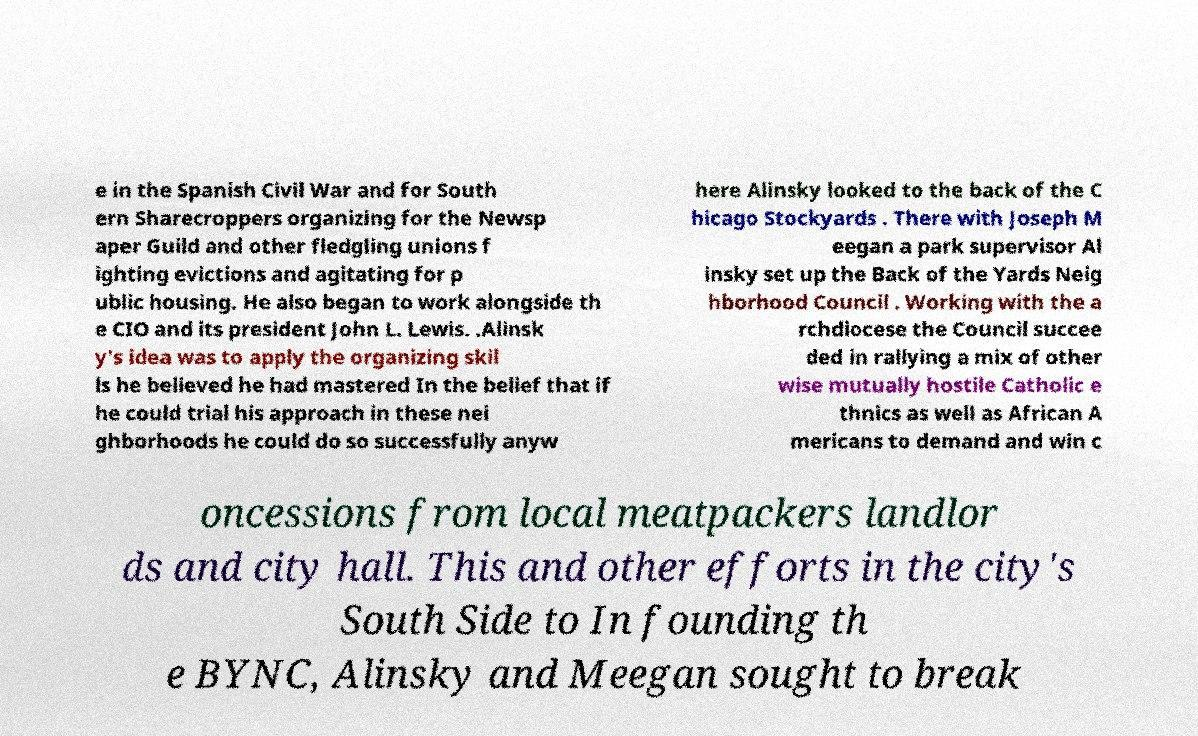Could you extract and type out the text from this image? e in the Spanish Civil War and for South ern Sharecroppers organizing for the Newsp aper Guild and other fledgling unions f ighting evictions and agitating for p ublic housing. He also began to work alongside th e CIO and its president John L. Lewis. .Alinsk y's idea was to apply the organizing skil ls he believed he had mastered In the belief that if he could trial his approach in these nei ghborhoods he could do so successfully anyw here Alinsky looked to the back of the C hicago Stockyards . There with Joseph M eegan a park supervisor Al insky set up the Back of the Yards Neig hborhood Council . Working with the a rchdiocese the Council succee ded in rallying a mix of other wise mutually hostile Catholic e thnics as well as African A mericans to demand and win c oncessions from local meatpackers landlor ds and city hall. This and other efforts in the city's South Side to In founding th e BYNC, Alinsky and Meegan sought to break 